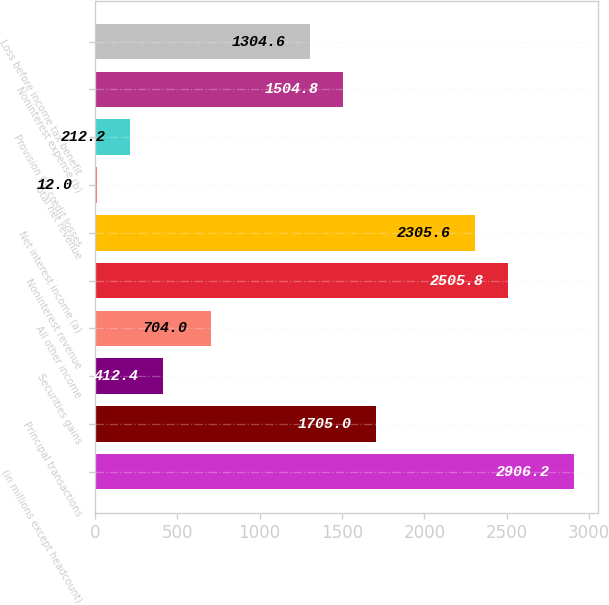<chart> <loc_0><loc_0><loc_500><loc_500><bar_chart><fcel>(in millions except headcount)<fcel>Principal transactions<fcel>Securities gains<fcel>All other income<fcel>Noninterest revenue<fcel>Net interest income (a)<fcel>Total net revenue<fcel>Provision for credit losses<fcel>Noninterest expense (b)<fcel>Loss before income tax benefit<nl><fcel>2906.2<fcel>1705<fcel>412.4<fcel>704<fcel>2505.8<fcel>2305.6<fcel>12<fcel>212.2<fcel>1504.8<fcel>1304.6<nl></chart> 